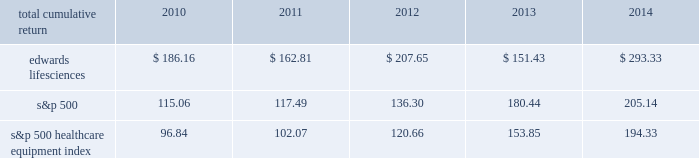12feb201521095992 performance graph the following graph compares the performance of our common stock with that of the s&p 500 index and the s&p 500 healthcare equipment index .
The cumulative total return listed below assumes an initial investment of $ 100 on december 31 , 2009 and reinvestment of dividends .
Comparison of 5 year cumulative total return rs $ 200 2009 2010 2011 201420132012 edwards lifesciences corporation s&p 500 s&p 500 healthcare equipment december 31 .

What was the difference in percentage 5 year cumulative total return between edwards lifesciences corporation and the s&p 500? 
Computations: (((293.33 - 100) / 100) - ((205.14 - 100) / 100))
Answer: 0.8819. 12feb201521095992 performance graph the following graph compares the performance of our common stock with that of the s&p 500 index and the s&p 500 healthcare equipment index .
The cumulative total return listed below assumes an initial investment of $ 100 on december 31 , 2009 and reinvestment of dividends .
Comparison of 5 year cumulative total return rs $ 200 2009 2010 2011 201420132012 edwards lifesciences corporation s&p 500 s&p 500 healthcare equipment december 31 .

What was the 5 year cumulative total return for the period ending 2014 for edwards lifesciences corporation? 
Computations: ((293.33 - 100) / 100)
Answer: 1.9333. 